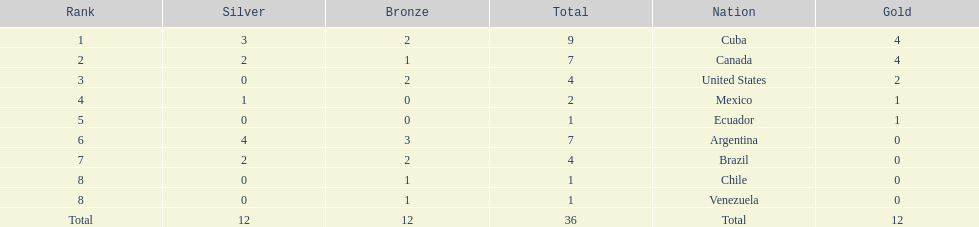Which country secured gold but failed to obtain silver? United States. 